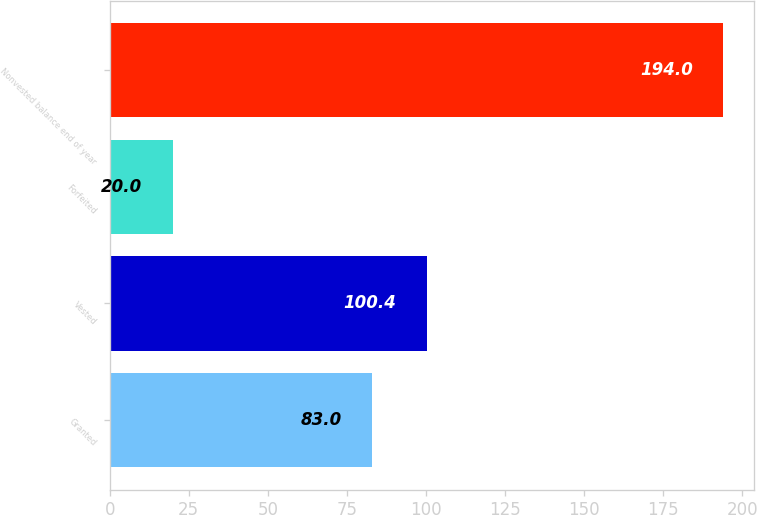<chart> <loc_0><loc_0><loc_500><loc_500><bar_chart><fcel>Granted<fcel>Vested<fcel>Forfeited<fcel>Nonvested balance end of year<nl><fcel>83<fcel>100.4<fcel>20<fcel>194<nl></chart> 